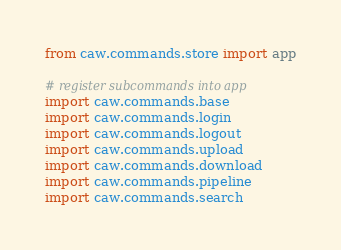<code> <loc_0><loc_0><loc_500><loc_500><_Python_>from caw.commands.store import app

# register subcommands into app
import caw.commands.base
import caw.commands.login
import caw.commands.logout
import caw.commands.upload
import caw.commands.download
import caw.commands.pipeline
import caw.commands.search
</code> 